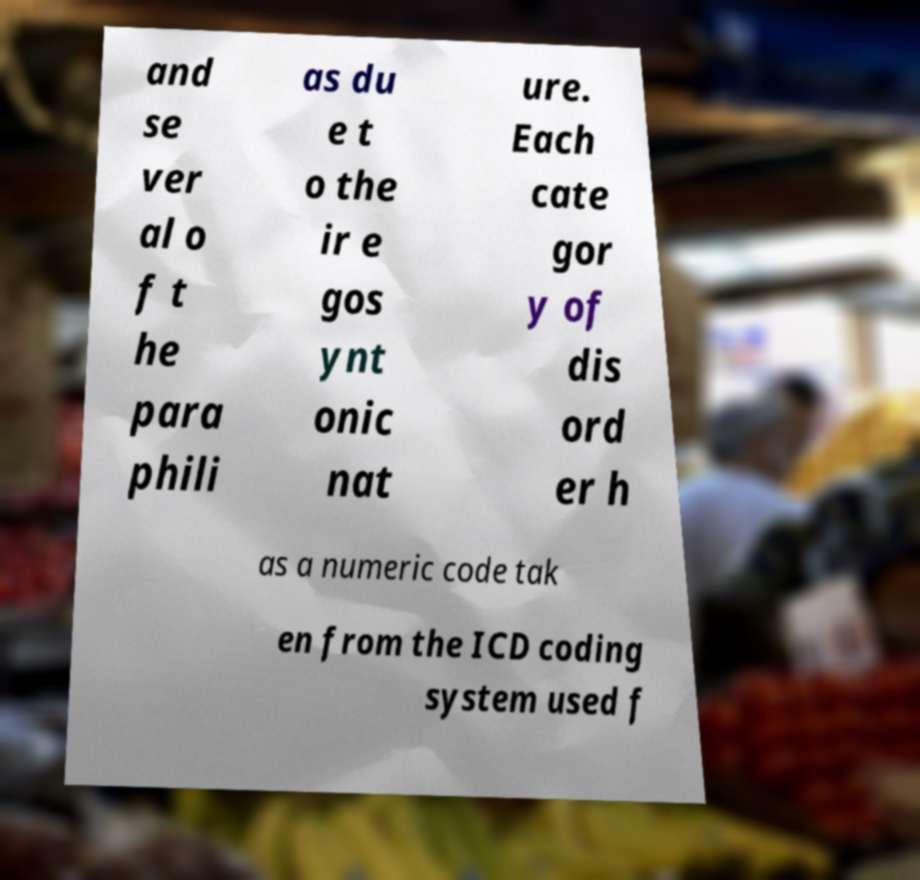There's text embedded in this image that I need extracted. Can you transcribe it verbatim? and se ver al o f t he para phili as du e t o the ir e gos ynt onic nat ure. Each cate gor y of dis ord er h as a numeric code tak en from the ICD coding system used f 